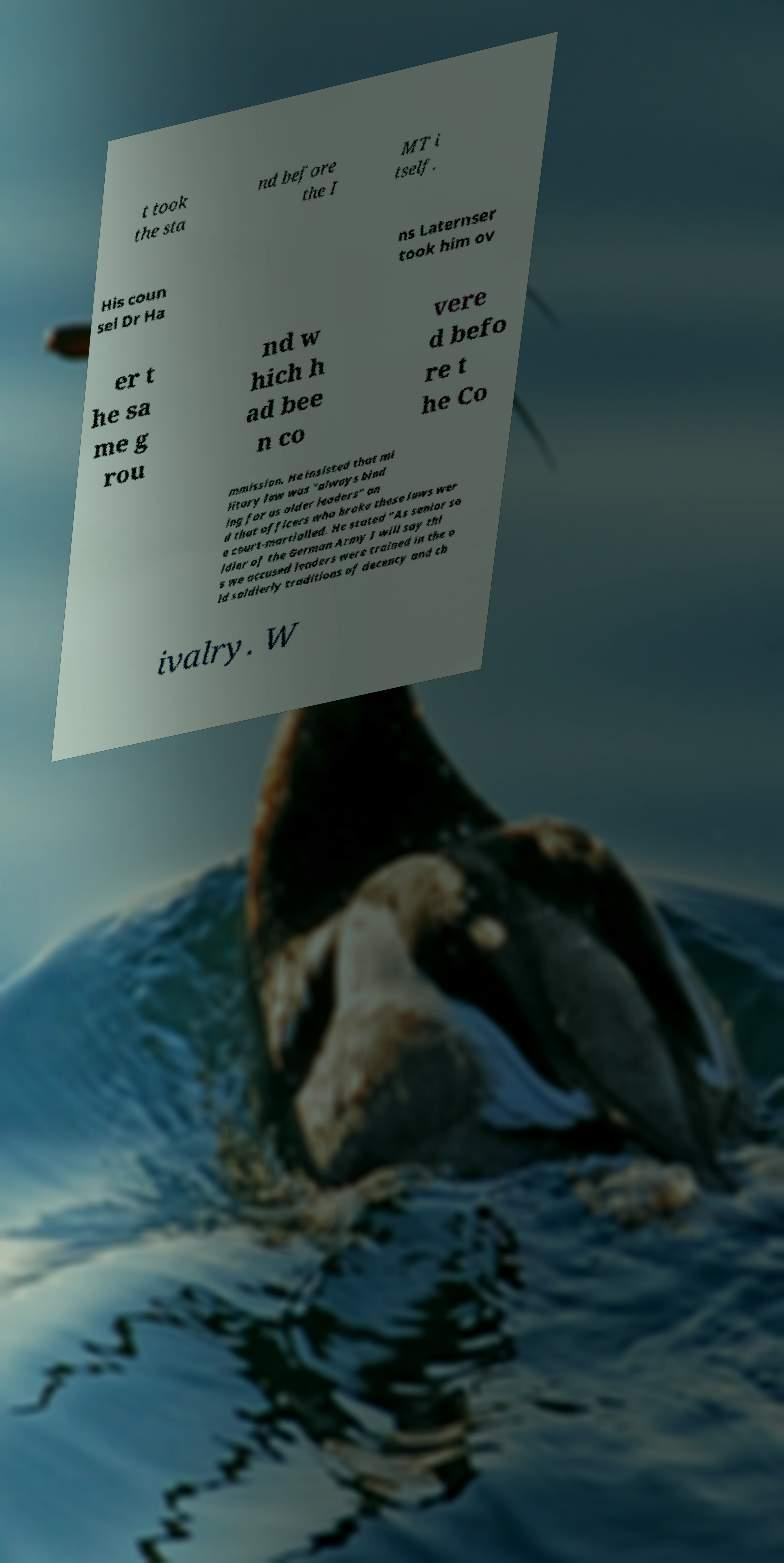For documentation purposes, I need the text within this image transcribed. Could you provide that? t took the sta nd before the I MT i tself. His coun sel Dr Ha ns Laternser took him ov er t he sa me g rou nd w hich h ad bee n co vere d befo re t he Co mmission. He insisted that mi litary law was "always bind ing for us older leaders" an d that officers who broke these laws wer e court-martialled. He stated "As senior so ldier of the German Army I will say thi s we accused leaders were trained in the o ld soldierly traditions of decency and ch ivalry. W 